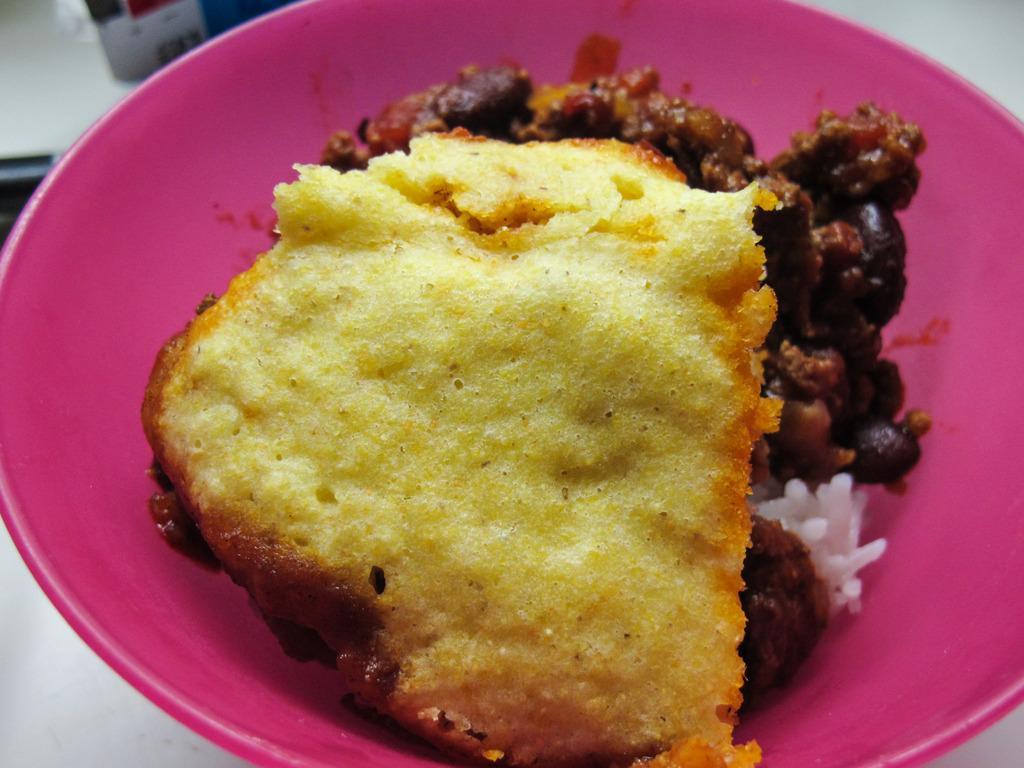Could you give a brief overview of what you see in this image? In this image there is a food item on the plate, on the object. 